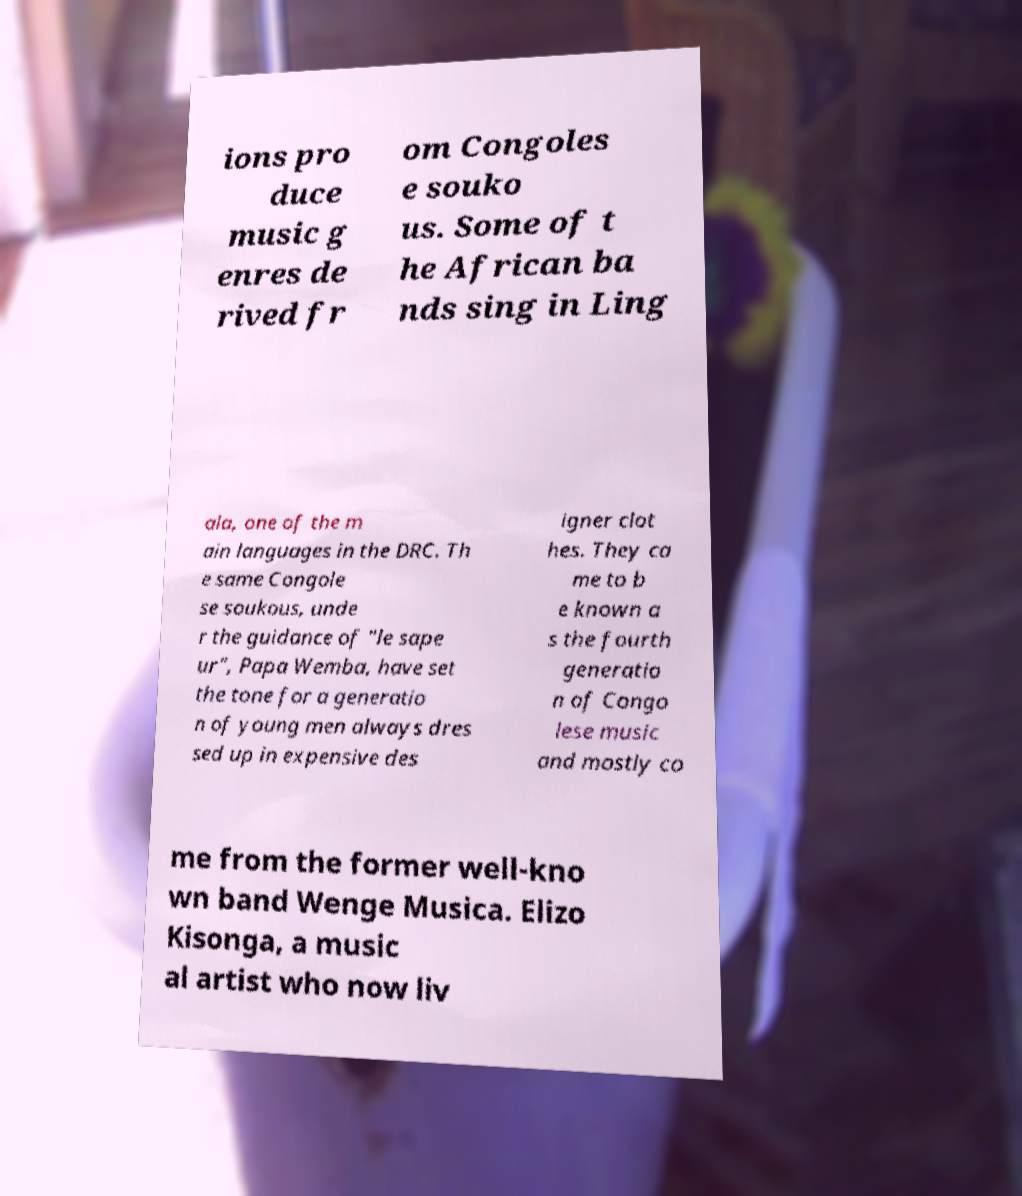Please identify and transcribe the text found in this image. ions pro duce music g enres de rived fr om Congoles e souko us. Some of t he African ba nds sing in Ling ala, one of the m ain languages in the DRC. Th e same Congole se soukous, unde r the guidance of "le sape ur", Papa Wemba, have set the tone for a generatio n of young men always dres sed up in expensive des igner clot hes. They ca me to b e known a s the fourth generatio n of Congo lese music and mostly co me from the former well-kno wn band Wenge Musica. Elizo Kisonga, a music al artist who now liv 